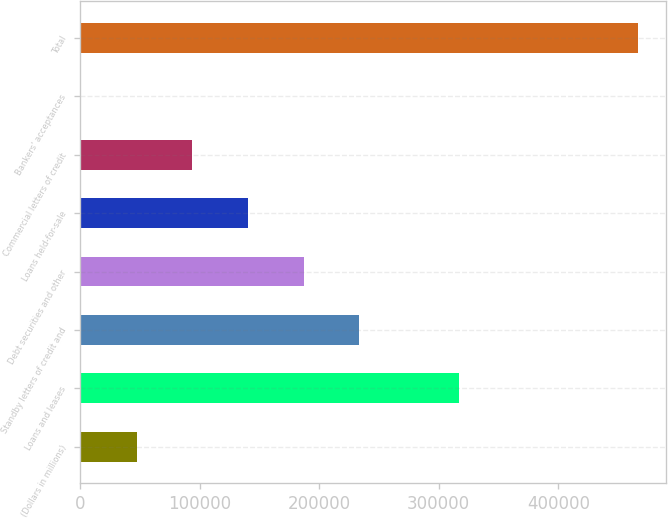Convert chart to OTSL. <chart><loc_0><loc_0><loc_500><loc_500><bar_chart><fcel>(Dollars in millions)<fcel>Loans and leases<fcel>Standby letters of credit and<fcel>Debt securities and other<fcel>Loans held-for-sale<fcel>Commercial letters of credit<fcel>Bankers' acceptances<fcel>Total<nl><fcel>47368.2<fcel>316816<fcel>233653<fcel>187082<fcel>140511<fcel>93939.4<fcel>797<fcel>466509<nl></chart> 